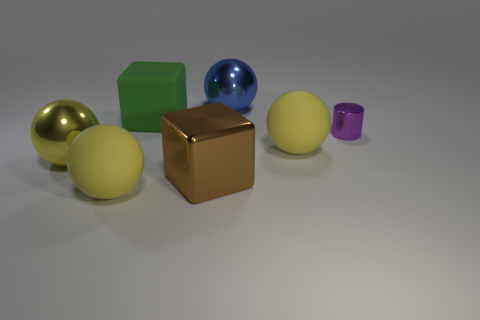Subtract all purple blocks. How many yellow spheres are left? 3 Subtract 2 spheres. How many spheres are left? 2 Subtract all blue balls. How many balls are left? 3 Subtract all large blue spheres. How many spheres are left? 3 Subtract all red spheres. Subtract all brown cylinders. How many spheres are left? 4 Add 1 brown shiny things. How many objects exist? 8 Subtract all cylinders. How many objects are left? 6 Subtract 0 gray balls. How many objects are left? 7 Subtract all big brown objects. Subtract all large spheres. How many objects are left? 2 Add 5 brown metallic objects. How many brown metallic objects are left? 6 